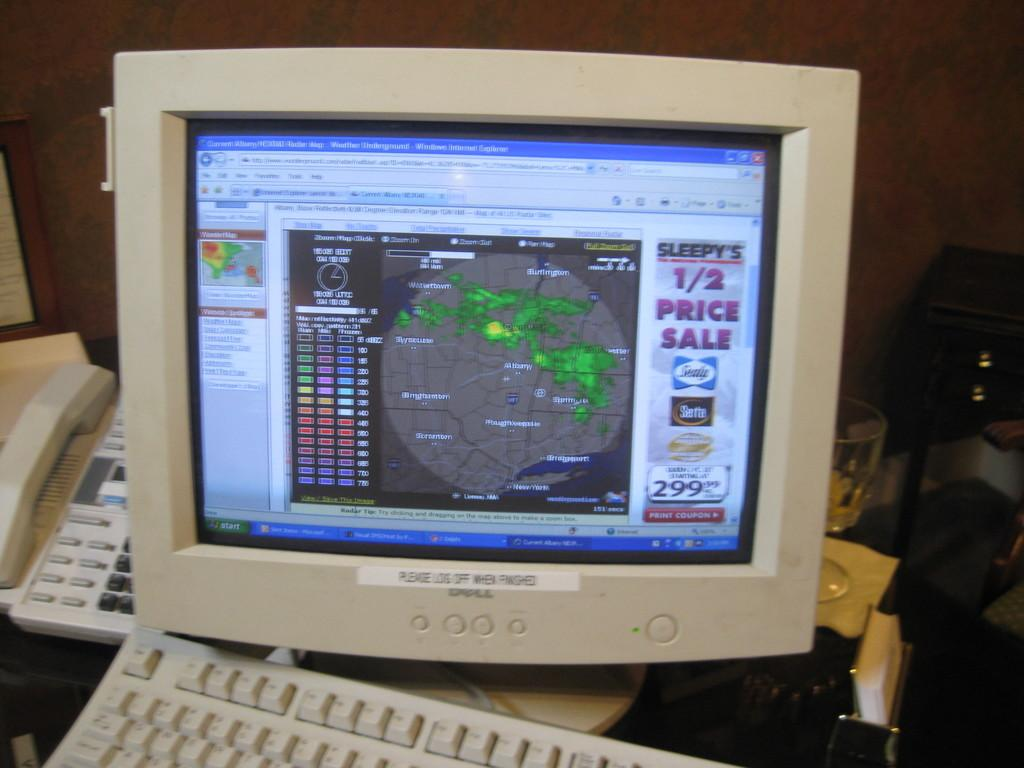<image>
Describe the image concisely. Sleepy's is having a 1/2 price sale, according to the computer monitor. 